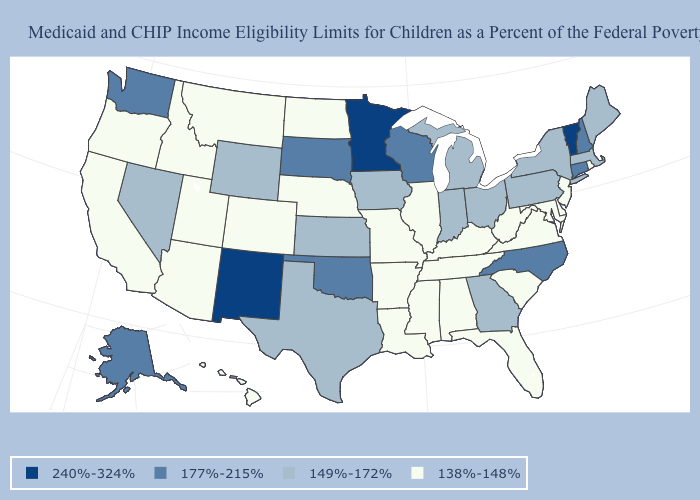Among the states that border Maine , which have the lowest value?
Short answer required. New Hampshire. Does South Carolina have a lower value than Texas?
Quick response, please. Yes. What is the value of New Jersey?
Short answer required. 138%-148%. Which states hav the highest value in the South?
Quick response, please. North Carolina, Oklahoma. Does the map have missing data?
Give a very brief answer. No. Name the states that have a value in the range 177%-215%?
Write a very short answer. Alaska, Connecticut, New Hampshire, North Carolina, Oklahoma, South Dakota, Washington, Wisconsin. Which states have the lowest value in the MidWest?
Give a very brief answer. Illinois, Missouri, Nebraska, North Dakota. Among the states that border West Virginia , does Virginia have the lowest value?
Concise answer only. Yes. Name the states that have a value in the range 149%-172%?
Write a very short answer. Georgia, Indiana, Iowa, Kansas, Maine, Massachusetts, Michigan, Nevada, New York, Ohio, Pennsylvania, Texas, Wyoming. Does Washington have the lowest value in the USA?
Answer briefly. No. What is the lowest value in the USA?
Concise answer only. 138%-148%. What is the highest value in states that border West Virginia?
Write a very short answer. 149%-172%. Name the states that have a value in the range 138%-148%?
Write a very short answer. Alabama, Arizona, Arkansas, California, Colorado, Delaware, Florida, Hawaii, Idaho, Illinois, Kentucky, Louisiana, Maryland, Mississippi, Missouri, Montana, Nebraska, New Jersey, North Dakota, Oregon, Rhode Island, South Carolina, Tennessee, Utah, Virginia, West Virginia. Does the first symbol in the legend represent the smallest category?
Concise answer only. No. Name the states that have a value in the range 177%-215%?
Short answer required. Alaska, Connecticut, New Hampshire, North Carolina, Oklahoma, South Dakota, Washington, Wisconsin. 